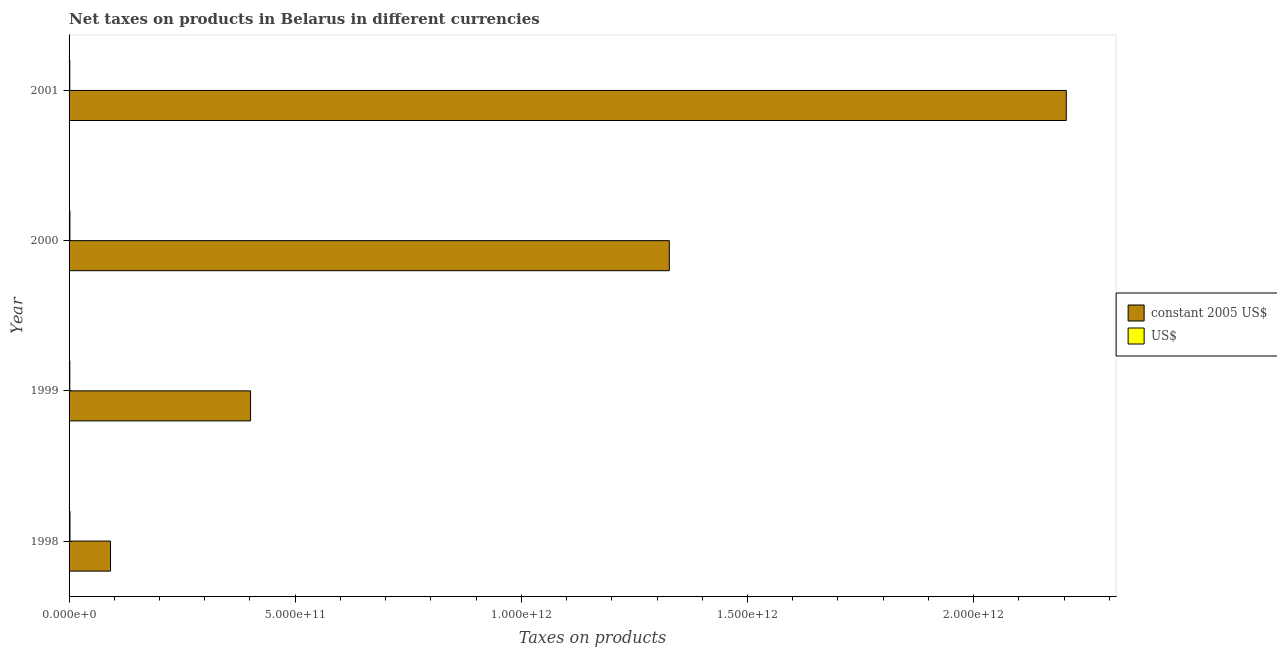Are the number of bars per tick equal to the number of legend labels?
Ensure brevity in your answer.  Yes. How many bars are there on the 3rd tick from the top?
Make the answer very short. 2. How many bars are there on the 3rd tick from the bottom?
Make the answer very short. 2. What is the label of the 4th group of bars from the top?
Offer a very short reply. 1998. What is the net taxes in us$ in 2000?
Your answer should be very brief. 1.85e+09. Across all years, what is the maximum net taxes in us$?
Provide a succinct answer. 1.99e+09. Across all years, what is the minimum net taxes in us$?
Keep it short and to the point. 1.59e+09. What is the total net taxes in us$ in the graph?
Make the answer very short. 7.03e+09. What is the difference between the net taxes in us$ in 1999 and that in 2000?
Offer a very short reply. -2.41e+08. What is the difference between the net taxes in constant 2005 us$ in 1999 and the net taxes in us$ in 1998?
Keep it short and to the point. 3.99e+11. What is the average net taxes in us$ per year?
Your answer should be very brief. 1.76e+09. In the year 1998, what is the difference between the net taxes in constant 2005 us$ and net taxes in us$?
Offer a terse response. 8.97e+1. What is the ratio of the net taxes in constant 2005 us$ in 1998 to that in 2001?
Provide a succinct answer. 0.04. Is the net taxes in constant 2005 us$ in 1999 less than that in 2000?
Your response must be concise. Yes. What is the difference between the highest and the second highest net taxes in us$?
Your answer should be very brief. 1.36e+08. What is the difference between the highest and the lowest net taxes in us$?
Offer a very short reply. 4.00e+08. In how many years, is the net taxes in us$ greater than the average net taxes in us$ taken over all years?
Your response must be concise. 2. What does the 2nd bar from the top in 2000 represents?
Your response must be concise. Constant 2005 us$. What does the 2nd bar from the bottom in 1998 represents?
Ensure brevity in your answer.  US$. How many bars are there?
Keep it short and to the point. 8. Are all the bars in the graph horizontal?
Your response must be concise. Yes. What is the difference between two consecutive major ticks on the X-axis?
Ensure brevity in your answer.  5.00e+11. Are the values on the major ticks of X-axis written in scientific E-notation?
Provide a short and direct response. Yes. Does the graph contain any zero values?
Your answer should be very brief. No. Does the graph contain grids?
Your answer should be very brief. No. How many legend labels are there?
Offer a terse response. 2. What is the title of the graph?
Offer a very short reply. Net taxes on products in Belarus in different currencies. Does "Nonresident" appear as one of the legend labels in the graph?
Provide a short and direct response. No. What is the label or title of the X-axis?
Make the answer very short. Taxes on products. What is the Taxes on products of constant 2005 US$ in 1998?
Your answer should be very brief. 9.16e+1. What is the Taxes on products of US$ in 1998?
Your answer should be very brief. 1.99e+09. What is the Taxes on products in constant 2005 US$ in 1999?
Give a very brief answer. 4.01e+11. What is the Taxes on products in US$ in 1999?
Your response must be concise. 1.61e+09. What is the Taxes on products of constant 2005 US$ in 2000?
Ensure brevity in your answer.  1.33e+12. What is the Taxes on products of US$ in 2000?
Provide a short and direct response. 1.85e+09. What is the Taxes on products of constant 2005 US$ in 2001?
Offer a terse response. 2.20e+12. What is the Taxes on products in US$ in 2001?
Your answer should be compact. 1.59e+09. Across all years, what is the maximum Taxes on products of constant 2005 US$?
Provide a succinct answer. 2.20e+12. Across all years, what is the maximum Taxes on products of US$?
Provide a succinct answer. 1.99e+09. Across all years, what is the minimum Taxes on products in constant 2005 US$?
Provide a short and direct response. 9.16e+1. Across all years, what is the minimum Taxes on products in US$?
Offer a very short reply. 1.59e+09. What is the total Taxes on products of constant 2005 US$ in the graph?
Your answer should be very brief. 4.02e+12. What is the total Taxes on products of US$ in the graph?
Your answer should be compact. 7.03e+09. What is the difference between the Taxes on products in constant 2005 US$ in 1998 and that in 1999?
Your answer should be very brief. -3.10e+11. What is the difference between the Taxes on products of US$ in 1998 and that in 1999?
Ensure brevity in your answer.  3.77e+08. What is the difference between the Taxes on products of constant 2005 US$ in 1998 and that in 2000?
Offer a very short reply. -1.24e+12. What is the difference between the Taxes on products in US$ in 1998 and that in 2000?
Your answer should be compact. 1.36e+08. What is the difference between the Taxes on products of constant 2005 US$ in 1998 and that in 2001?
Keep it short and to the point. -2.11e+12. What is the difference between the Taxes on products in US$ in 1998 and that in 2001?
Provide a short and direct response. 4.00e+08. What is the difference between the Taxes on products of constant 2005 US$ in 1999 and that in 2000?
Provide a succinct answer. -9.26e+11. What is the difference between the Taxes on products in US$ in 1999 and that in 2000?
Give a very brief answer. -2.41e+08. What is the difference between the Taxes on products in constant 2005 US$ in 1999 and that in 2001?
Make the answer very short. -1.80e+12. What is the difference between the Taxes on products in US$ in 1999 and that in 2001?
Offer a terse response. 2.34e+07. What is the difference between the Taxes on products of constant 2005 US$ in 2000 and that in 2001?
Give a very brief answer. -8.78e+11. What is the difference between the Taxes on products in US$ in 2000 and that in 2001?
Your response must be concise. 2.64e+08. What is the difference between the Taxes on products in constant 2005 US$ in 1998 and the Taxes on products in US$ in 1999?
Ensure brevity in your answer.  9.00e+1. What is the difference between the Taxes on products of constant 2005 US$ in 1998 and the Taxes on products of US$ in 2000?
Make the answer very short. 8.98e+1. What is the difference between the Taxes on products in constant 2005 US$ in 1998 and the Taxes on products in US$ in 2001?
Offer a terse response. 9.01e+1. What is the difference between the Taxes on products in constant 2005 US$ in 1999 and the Taxes on products in US$ in 2000?
Keep it short and to the point. 3.99e+11. What is the difference between the Taxes on products in constant 2005 US$ in 1999 and the Taxes on products in US$ in 2001?
Offer a terse response. 4.00e+11. What is the difference between the Taxes on products of constant 2005 US$ in 2000 and the Taxes on products of US$ in 2001?
Provide a succinct answer. 1.33e+12. What is the average Taxes on products in constant 2005 US$ per year?
Provide a succinct answer. 1.01e+12. What is the average Taxes on products of US$ per year?
Provide a succinct answer. 1.76e+09. In the year 1998, what is the difference between the Taxes on products of constant 2005 US$ and Taxes on products of US$?
Offer a terse response. 8.97e+1. In the year 1999, what is the difference between the Taxes on products in constant 2005 US$ and Taxes on products in US$?
Offer a terse response. 4.00e+11. In the year 2000, what is the difference between the Taxes on products in constant 2005 US$ and Taxes on products in US$?
Ensure brevity in your answer.  1.33e+12. In the year 2001, what is the difference between the Taxes on products of constant 2005 US$ and Taxes on products of US$?
Your answer should be very brief. 2.20e+12. What is the ratio of the Taxes on products of constant 2005 US$ in 1998 to that in 1999?
Provide a short and direct response. 0.23. What is the ratio of the Taxes on products in US$ in 1998 to that in 1999?
Provide a short and direct response. 1.23. What is the ratio of the Taxes on products in constant 2005 US$ in 1998 to that in 2000?
Provide a short and direct response. 0.07. What is the ratio of the Taxes on products of US$ in 1998 to that in 2000?
Offer a terse response. 1.07. What is the ratio of the Taxes on products in constant 2005 US$ in 1998 to that in 2001?
Your answer should be compact. 0.04. What is the ratio of the Taxes on products in US$ in 1998 to that in 2001?
Provide a succinct answer. 1.25. What is the ratio of the Taxes on products in constant 2005 US$ in 1999 to that in 2000?
Your answer should be very brief. 0.3. What is the ratio of the Taxes on products in US$ in 1999 to that in 2000?
Keep it short and to the point. 0.87. What is the ratio of the Taxes on products of constant 2005 US$ in 1999 to that in 2001?
Ensure brevity in your answer.  0.18. What is the ratio of the Taxes on products in US$ in 1999 to that in 2001?
Offer a very short reply. 1.01. What is the ratio of the Taxes on products in constant 2005 US$ in 2000 to that in 2001?
Provide a succinct answer. 0.6. What is the ratio of the Taxes on products in US$ in 2000 to that in 2001?
Your response must be concise. 1.17. What is the difference between the highest and the second highest Taxes on products of constant 2005 US$?
Your response must be concise. 8.78e+11. What is the difference between the highest and the second highest Taxes on products of US$?
Provide a succinct answer. 1.36e+08. What is the difference between the highest and the lowest Taxes on products in constant 2005 US$?
Your response must be concise. 2.11e+12. What is the difference between the highest and the lowest Taxes on products in US$?
Provide a short and direct response. 4.00e+08. 